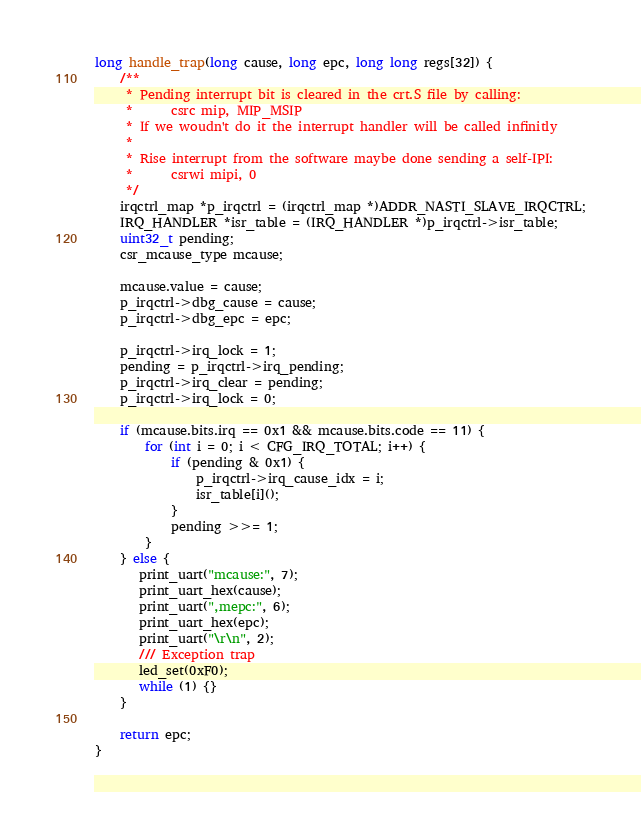<code> <loc_0><loc_0><loc_500><loc_500><_C_>
long handle_trap(long cause, long epc, long long regs[32]) {
    /**
     * Pending interrupt bit is cleared in the crt.S file by calling:
     *      csrc mip, MIP_MSIP
     * If we woudn't do it the interrupt handler will be called infinitly
     *
     * Rise interrupt from the software maybe done sending a self-IPI:
     *      csrwi mipi, 0
     */
    irqctrl_map *p_irqctrl = (irqctrl_map *)ADDR_NASTI_SLAVE_IRQCTRL;
    IRQ_HANDLER *isr_table = (IRQ_HANDLER *)p_irqctrl->isr_table;
    uint32_t pending;
    csr_mcause_type mcause;

    mcause.value = cause;
    p_irqctrl->dbg_cause = cause;
    p_irqctrl->dbg_epc = epc;

    p_irqctrl->irq_lock = 1;
    pending = p_irqctrl->irq_pending;
    p_irqctrl->irq_clear = pending;
    p_irqctrl->irq_lock = 0;

    if (mcause.bits.irq == 0x1 && mcause.bits.code == 11) {
        for (int i = 0; i < CFG_IRQ_TOTAL; i++) {
            if (pending & 0x1) {
                p_irqctrl->irq_cause_idx = i;
                isr_table[i]();
            }
            pending >>= 1;
        }
    } else {
       print_uart("mcause:", 7);
       print_uart_hex(cause);
       print_uart(",mepc:", 6);
       print_uart_hex(epc);
       print_uart("\r\n", 2);
       /// Exception trap
       led_set(0xF0);
       while (1) {}
    }

    return epc;
}
</code> 